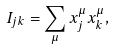Convert formula to latex. <formula><loc_0><loc_0><loc_500><loc_500>I _ { j k } = \sum _ { \mu } x _ { j } ^ { \mu } x _ { k } ^ { \mu } ,</formula> 